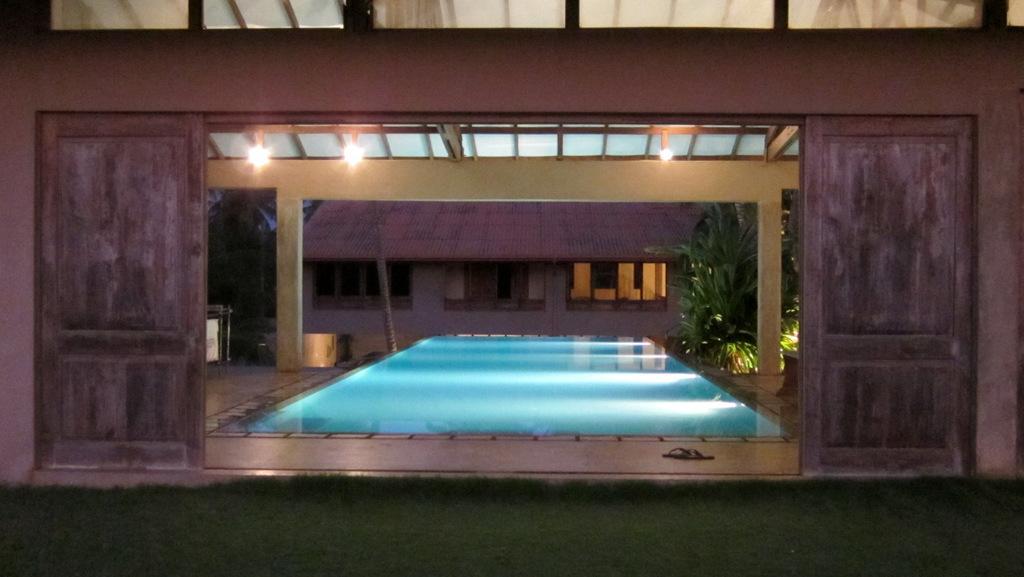How would you summarize this image in a sentence or two? In this image I see the grass over here and I see the wall and I see the pool over here and I see the path and I see the footwear over here. In the background I see the house and I see few plants and I see the lights on the ceiling. 